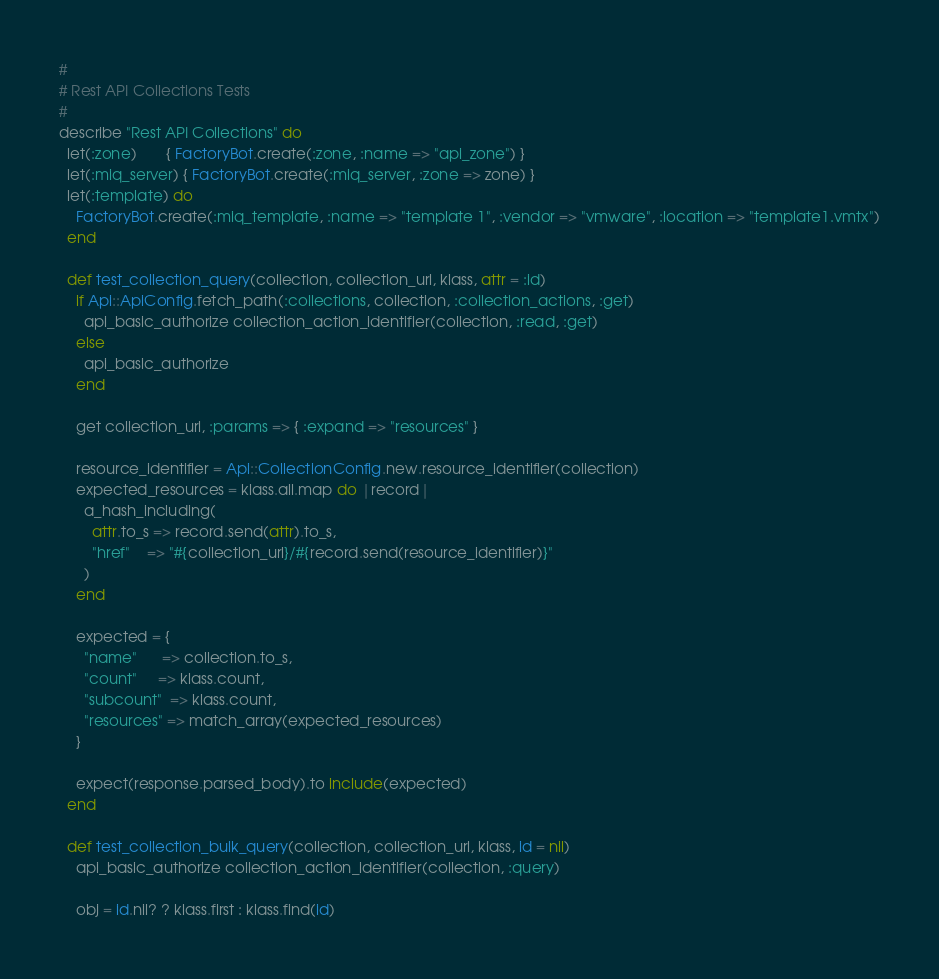Convert code to text. <code><loc_0><loc_0><loc_500><loc_500><_Ruby_>#
# Rest API Collections Tests
#
describe "Rest API Collections" do
  let(:zone)       { FactoryBot.create(:zone, :name => "api_zone") }
  let(:miq_server) { FactoryBot.create(:miq_server, :zone => zone) }
  let(:template) do
    FactoryBot.create(:miq_template, :name => "template 1", :vendor => "vmware", :location => "template1.vmtx")
  end

  def test_collection_query(collection, collection_url, klass, attr = :id)
    if Api::ApiConfig.fetch_path(:collections, collection, :collection_actions, :get)
      api_basic_authorize collection_action_identifier(collection, :read, :get)
    else
      api_basic_authorize
    end

    get collection_url, :params => { :expand => "resources" }

    resource_identifier = Api::CollectionConfig.new.resource_identifier(collection)
    expected_resources = klass.all.map do |record|
      a_hash_including(
        attr.to_s => record.send(attr).to_s,
        "href"    => "#{collection_url}/#{record.send(resource_identifier)}"
      )
    end

    expected = {
      "name"      => collection.to_s,
      "count"     => klass.count,
      "subcount"  => klass.count,
      "resources" => match_array(expected_resources)
    }

    expect(response.parsed_body).to include(expected)
  end

  def test_collection_bulk_query(collection, collection_url, klass, id = nil)
    api_basic_authorize collection_action_identifier(collection, :query)

    obj = id.nil? ? klass.first : klass.find(id)</code> 